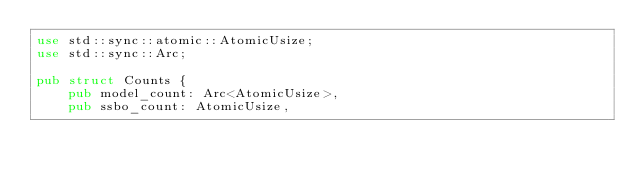<code> <loc_0><loc_0><loc_500><loc_500><_Rust_>use std::sync::atomic::AtomicUsize;
use std::sync::Arc;

pub struct Counts {
    pub model_count: Arc<AtomicUsize>,
    pub ssbo_count: AtomicUsize,</code> 